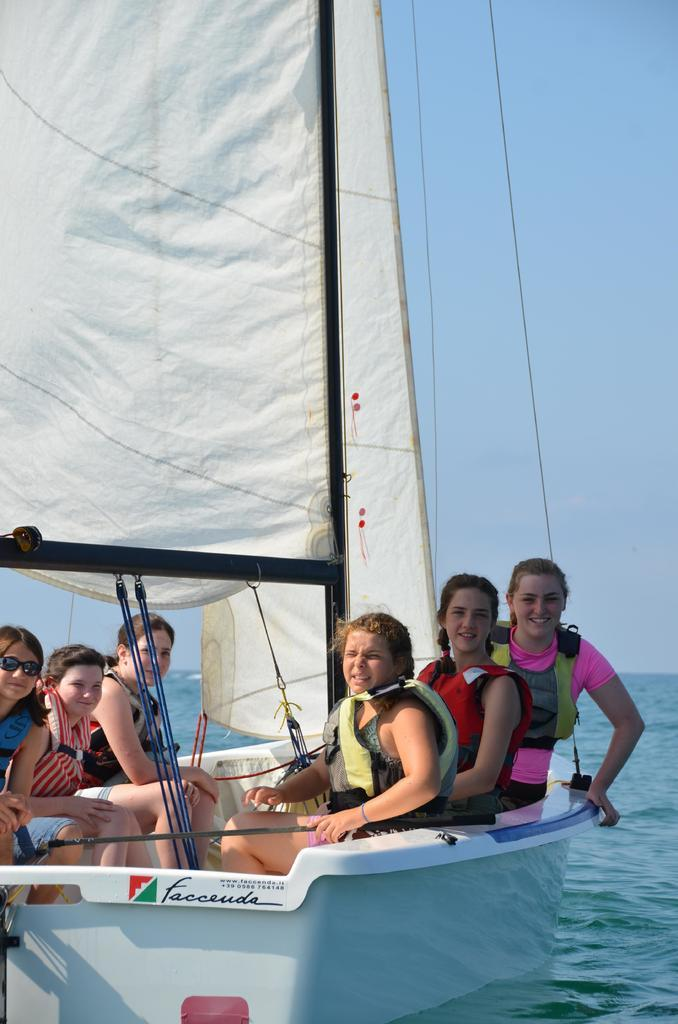What is the main subject of the image? The main subject of the image is a boat. What is happening with the boat in the image? There is a group of people sitting in the boat. What type of environment is depicted in the image? There is water visible in the image, suggesting a water-based setting. What is visible at the top of the image? The sky is visible at the top of the image. Where is the tramp located in the image? There is no tramp present in the image. What time does the mailbox deliver mail in the image? There is no mailbox present in the image. 